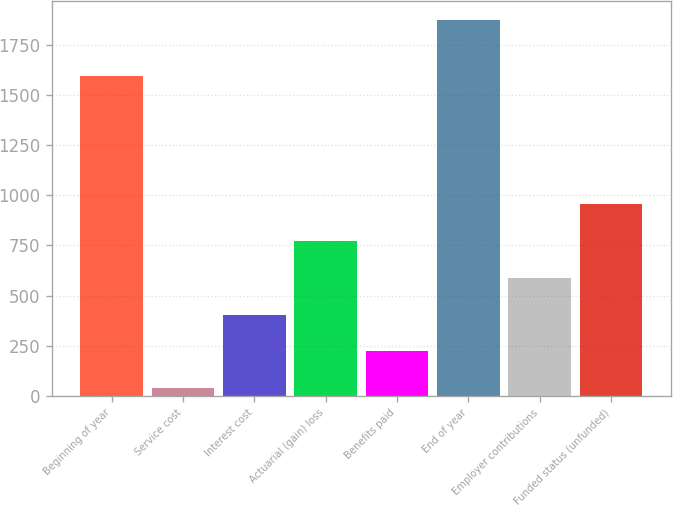Convert chart. <chart><loc_0><loc_0><loc_500><loc_500><bar_chart><fcel>Beginning of year<fcel>Service cost<fcel>Interest cost<fcel>Actuarial (gain) loss<fcel>Benefits paid<fcel>End of year<fcel>Employer contributions<fcel>Funded status (unfunded)<nl><fcel>1594<fcel>38<fcel>405<fcel>772<fcel>221.5<fcel>1873<fcel>588.5<fcel>955.5<nl></chart> 